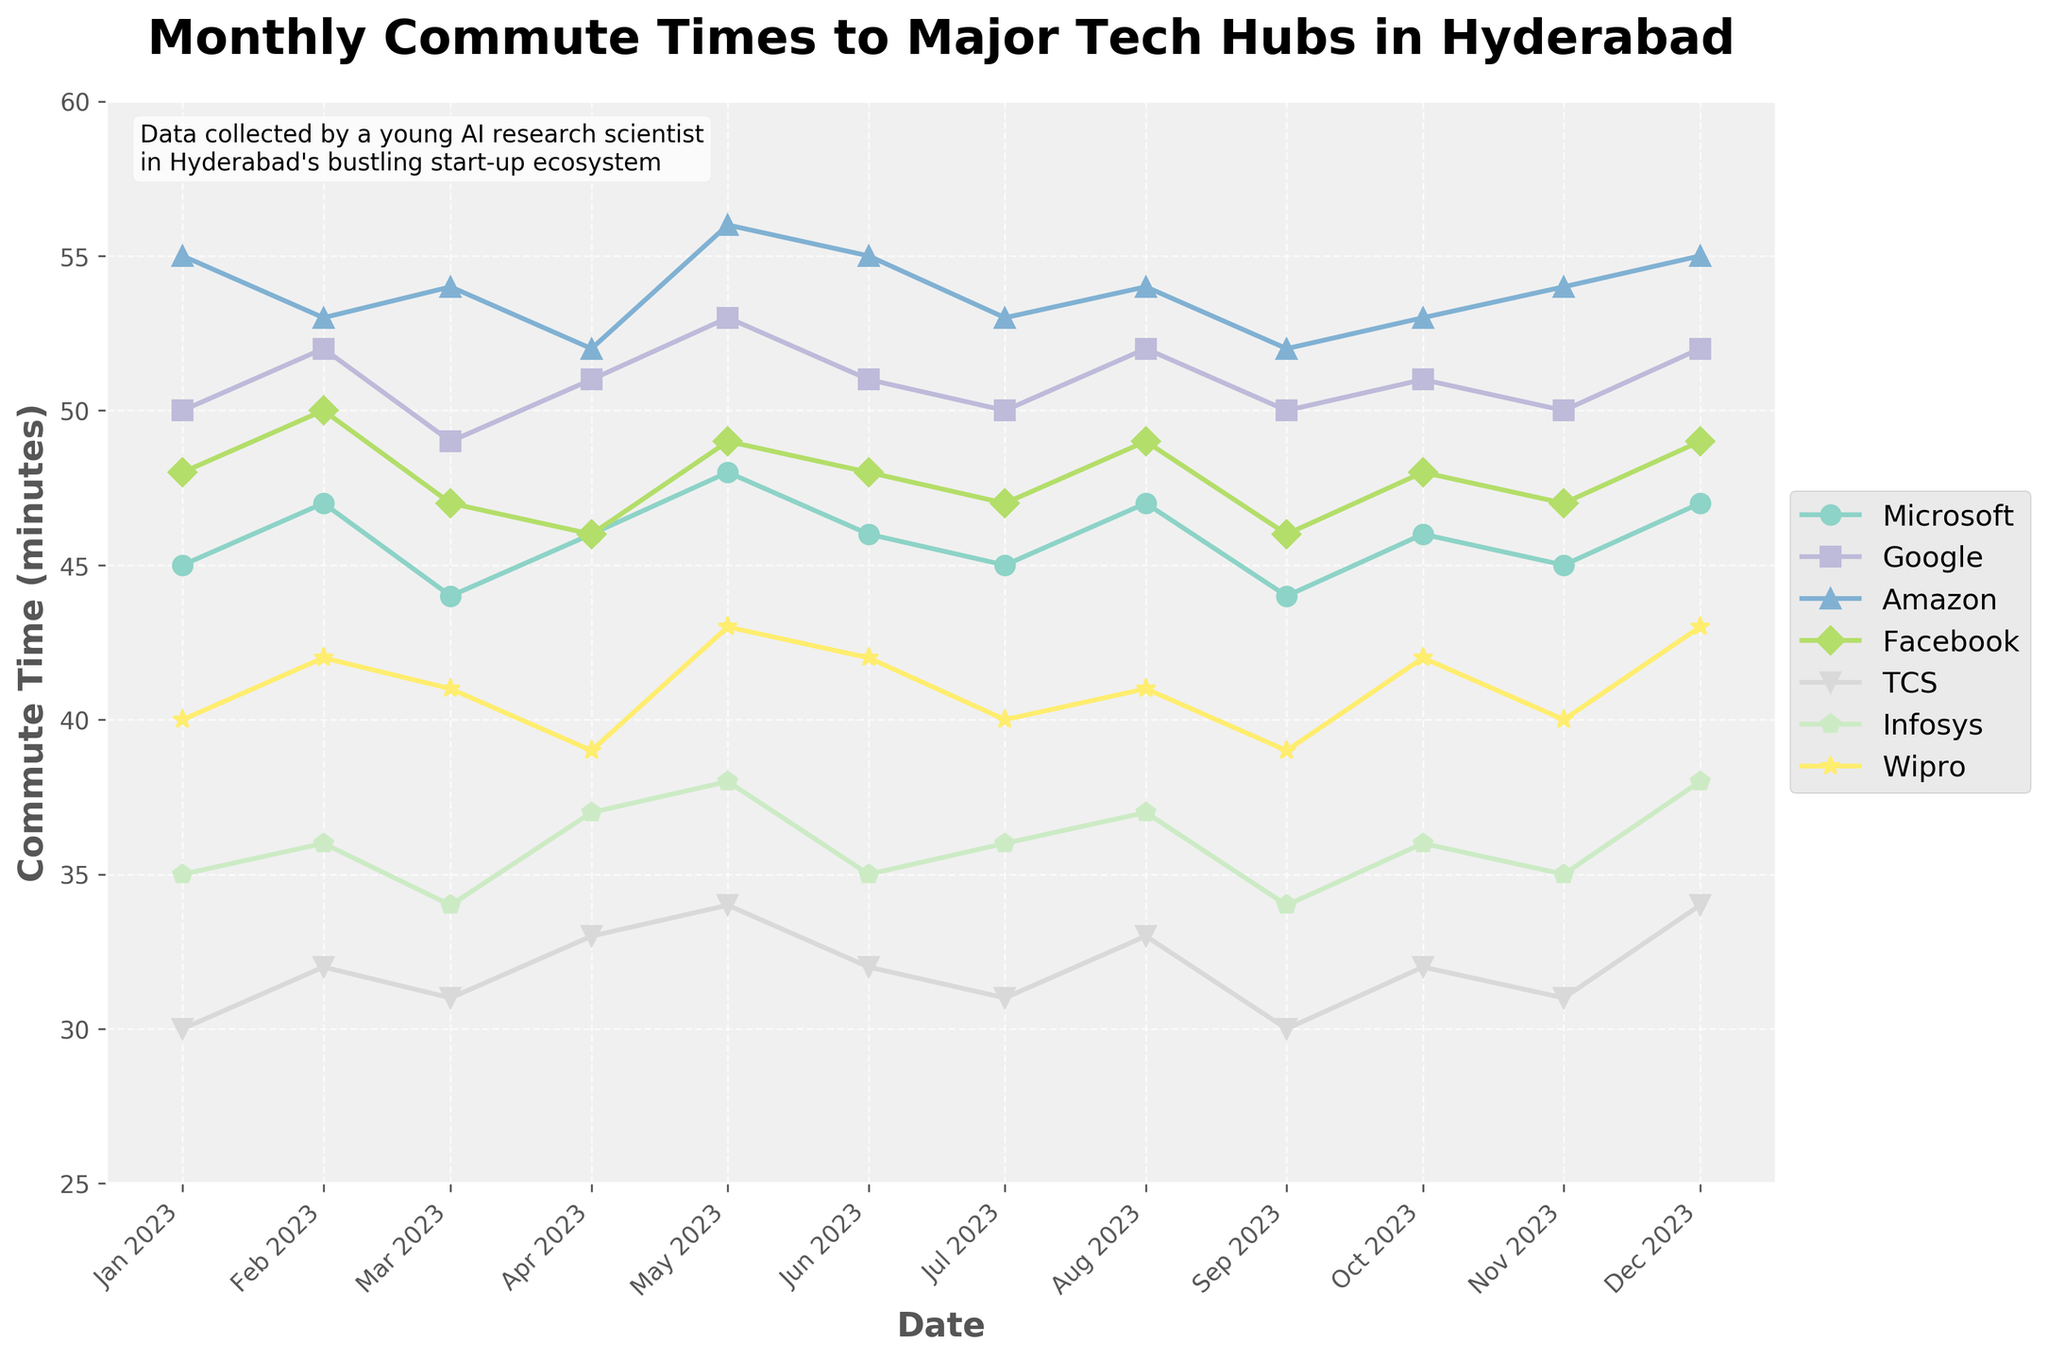How many companies are displayed in the plot? The plot lines represent different companies, each of them having a unique color and marker. Count the names of the companies in the legend.
Answer: 7 Which company has the highest average commute time over the year? To find the highest average commute time, sum up the monthly commute times for each company over the entire year and then divide by the number of months (12). Specifically, Amazon: (55 + 53 + 54 + 52 + 56 + 55 + 53 + 54 + 52 + 53 + 54 + 55) / 12 = 53.58. Google: (50 + 52 + 49 + 51 + 53 + 51 + 50 + 52 + 50 + 51 + 50 + 52) / 12 = 51. The highest average commute time is therefore Amazon.
Answer: Amazon In which month did TCS have the lowest commute time? Check each data point for TCS across all months and identify the lowest value. TCS has its lowest commute time of 30 minutes in January and September.
Answer: January and September Which two companies have the most similar commute times in October? Compare the commute times for October for each pair of companies by checking the values. In October, Microsoft: 46, Google: 51, Amazon: 53, Facebook: 48, TCS: 32, Infosys: 36, Wipro: 42. The two closest values are Microsoft (46) and Facebook (48).
Answer: Microsoft and Facebook What is the trend for Infosys commute times throughout the year? To describe the trend, observe the plot line for Infosys. It starts at 35 in January, fluctuates slightly, and ends at 38 in December. The general trend appears to be slightly increasing.
Answer: Slightly increasing How did the commute time for Facebook change from March to April? To see the change for Facebook, look for the difference between the March value (47) and the April value (46). Therefore, the commute time slightly decreased.
Answer: Decreased by 1 minute What was the most common commute time range for Wipro? By examining the plot line for Wipro, most of the values seem to be around 40 minutes with slight fluctuations. Specifically, 40-minute range occurs multiple times in January, July, September, November.
Answer: Around 40 minutes Which month showed the greatest variation in commute times across the companies? The variation can be deduced by finding the range between the maximum and minimum commute times for each month. For instance, May has Amazon at 56 and TCS at 34 with a range of 22 minutes (56-34). Check all months similarly to confirm May has the largest range.
Answer: May How does the average commute time for Google compare with the average commute time for TCS? Calculate the average as shown in question 2. Google: 51, TCS: (30 + 32 + 31 + 33 + 34 + 32 + 31 + 33 + 30 + 32 + 31 + 34) / 12 = 32.25. Google’s average commute time is higher.
Answer: Higher Which company had a relatively stable commute time throughout the year? A stable commute time means small fluctuations. Check the plot lines for each company for fluctuations. Microsoft shows relatively consistent values close to 45-47 throughout the year.
Answer: Microsoft 